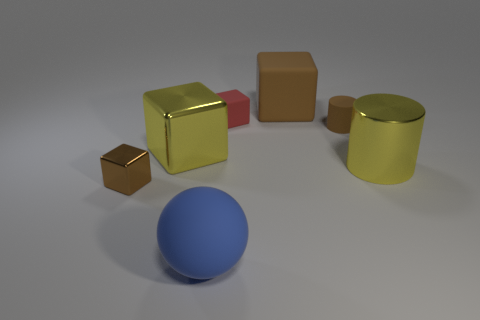Can you describe the arrangement and colors of the other objects in the image? Certainly! In addition to the small brown block, there's a large yellow shiny cube and a matte cylinder, both also in yellow shades. Centered in the foreground, there's a blue matte sphere. The objects are on a surface that fades from a white spotlight to a surrounding gray area. 